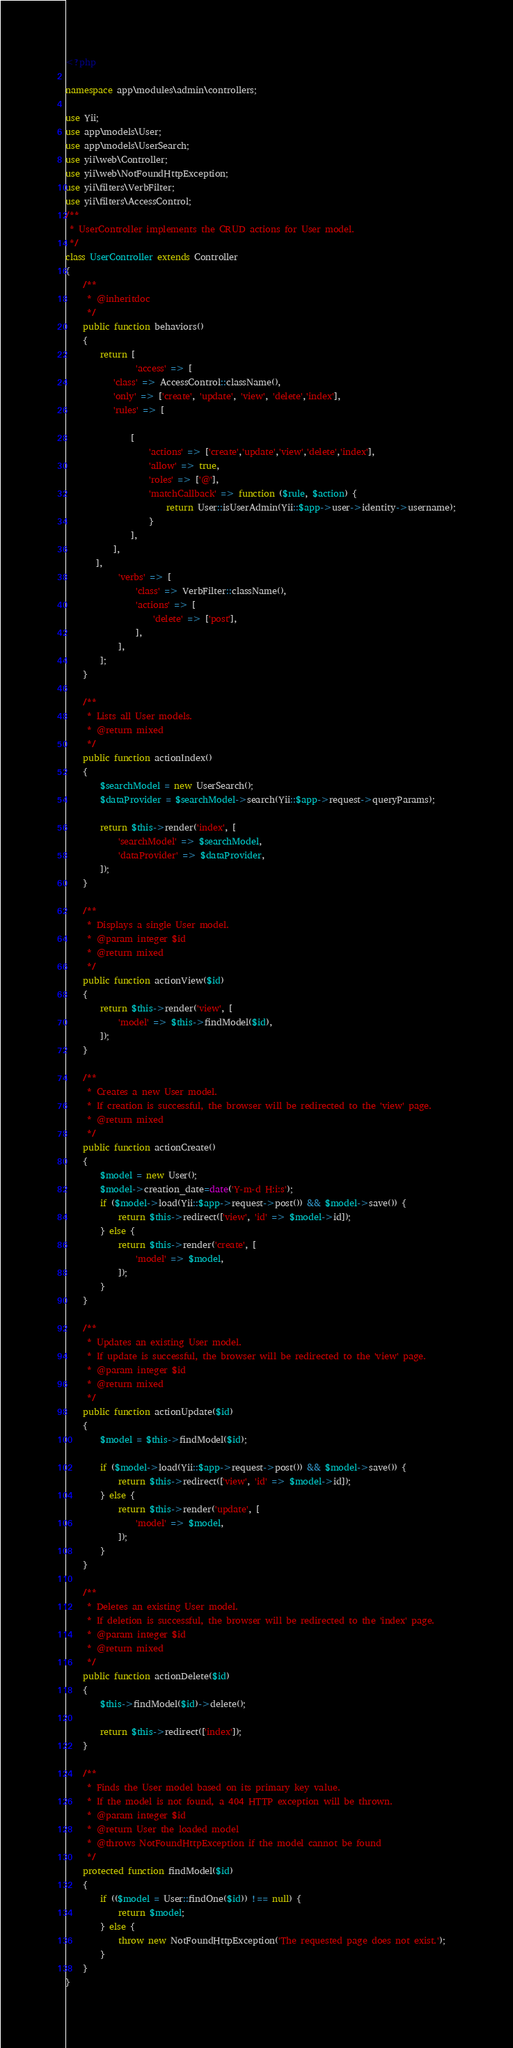<code> <loc_0><loc_0><loc_500><loc_500><_PHP_><?php

namespace app\modules\admin\controllers;

use Yii;
use app\models\User;
use app\models\UserSearch;
use yii\web\Controller;
use yii\web\NotFoundHttpException;
use yii\filters\VerbFilter;
use yii\filters\AccessControl;
/**
 * UserController implements the CRUD actions for User model.
 */
class UserController extends Controller
{
    /**
     * @inheritdoc
     */
    public function behaviors()
    {
        return [
                'access' => [
           'class' => AccessControl::className(),
           'only' => ['create', 'update', 'view', 'delete','index'],
           'rules' => [

               [
                   'actions' => ['create','update','view','delete','index'],
                   'allow' => true,
                   'roles' => ['@'],
                   'matchCallback' => function ($rule, $action) {
                       return User::isUserAdmin(Yii::$app->user->identity->username);
                   }
               ],
           ],
       ],
            'verbs' => [
                'class' => VerbFilter::className(),
                'actions' => [
                    'delete' => ['post'],
                ],
            ],
        ];
    }

    /**
     * Lists all User models.
     * @return mixed
     */
    public function actionIndex()
    {
        $searchModel = new UserSearch();
        $dataProvider = $searchModel->search(Yii::$app->request->queryParams);

        return $this->render('index', [
            'searchModel' => $searchModel,
            'dataProvider' => $dataProvider,
        ]);
    }

    /**
     * Displays a single User model.
     * @param integer $id
     * @return mixed
     */
    public function actionView($id)
    {
        return $this->render('view', [
            'model' => $this->findModel($id),
        ]);
    }

    /**
     * Creates a new User model.
     * If creation is successful, the browser will be redirected to the 'view' page.
     * @return mixed
     */
    public function actionCreate()
    {
        $model = new User();
        $model->creation_date=date('Y-m-d H:i:s');
        if ($model->load(Yii::$app->request->post()) && $model->save()) {
            return $this->redirect(['view', 'id' => $model->id]);
        } else {
            return $this->render('create', [
                'model' => $model,
            ]);
        }
    }

    /**
     * Updates an existing User model.
     * If update is successful, the browser will be redirected to the 'view' page.
     * @param integer $id
     * @return mixed
     */
    public function actionUpdate($id)
    {
        $model = $this->findModel($id);

        if ($model->load(Yii::$app->request->post()) && $model->save()) {
            return $this->redirect(['view', 'id' => $model->id]);
        } else {
            return $this->render('update', [
                'model' => $model,
            ]);
        }
    }

    /**
     * Deletes an existing User model.
     * If deletion is successful, the browser will be redirected to the 'index' page.
     * @param integer $id
     * @return mixed
     */
    public function actionDelete($id)
    {
        $this->findModel($id)->delete();

        return $this->redirect(['index']);
    }

    /**
     * Finds the User model based on its primary key value.
     * If the model is not found, a 404 HTTP exception will be thrown.
     * @param integer $id
     * @return User the loaded model
     * @throws NotFoundHttpException if the model cannot be found
     */
    protected function findModel($id)
    {
        if (($model = User::findOne($id)) !== null) {
            return $model;
        } else {
            throw new NotFoundHttpException('The requested page does not exist.');
        }
    }
}
</code> 